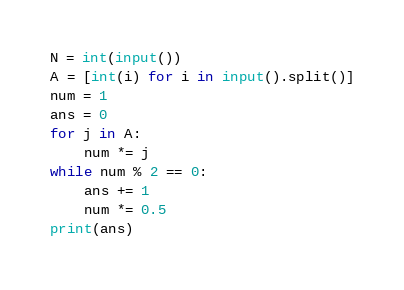Convert code to text. <code><loc_0><loc_0><loc_500><loc_500><_Python_>N = int(input())
A = [int(i) for i in input().split()]
num = 1
ans = 0
for j in A:
    num *= j
while num % 2 == 0:
    ans += 1
    num *= 0.5
print(ans)</code> 